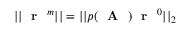Convert formula to latex. <formula><loc_0><loc_0><loc_500><loc_500>| | r ^ { m } | | = | | p ( A ) r ^ { 0 } | | _ { 2 }</formula> 